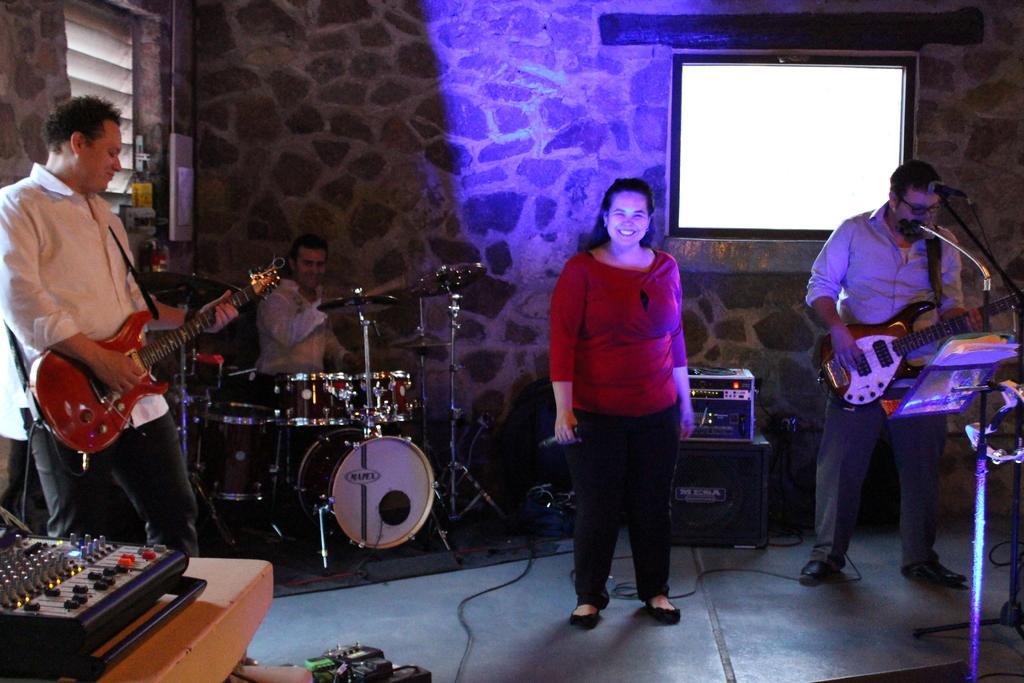Could you give a brief overview of what you see in this image? there are so many people standing holding a musical instruments is playing a music and there is a woman in the middle holding a microphone is smiling. 